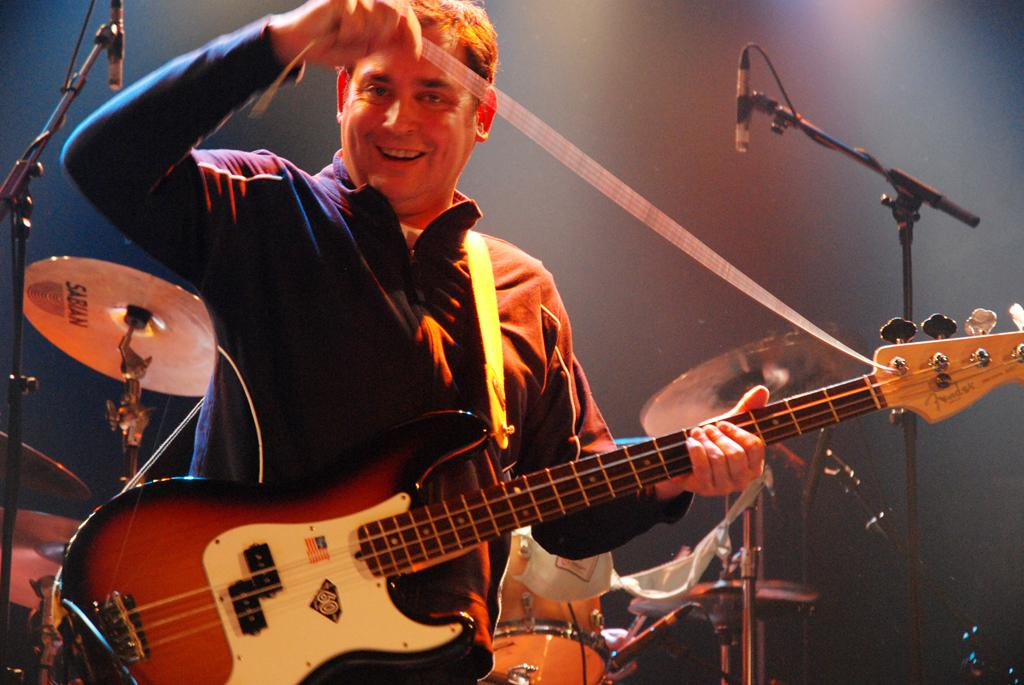Who is present in the image? There is a man in the image. What is the man holding in the image? The man is holding a guitar. What musical instruments can be seen in the background of the image? There are drums, cymbals, and microphones in the background of the image. What type of punishment is being administered to the man in the image? There is no punishment being administered to the man in the image; he is simply holding a guitar. Can you describe the volcano in the image? There is no volcano present in the image. 